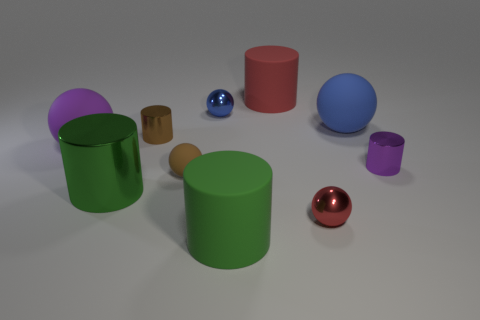If these objects were real, what could be their potential uses? If these were real objects, the cylinders could serve as containers or storage elements, while the spheres might be used as decorative items or in games that require ball-like items. 